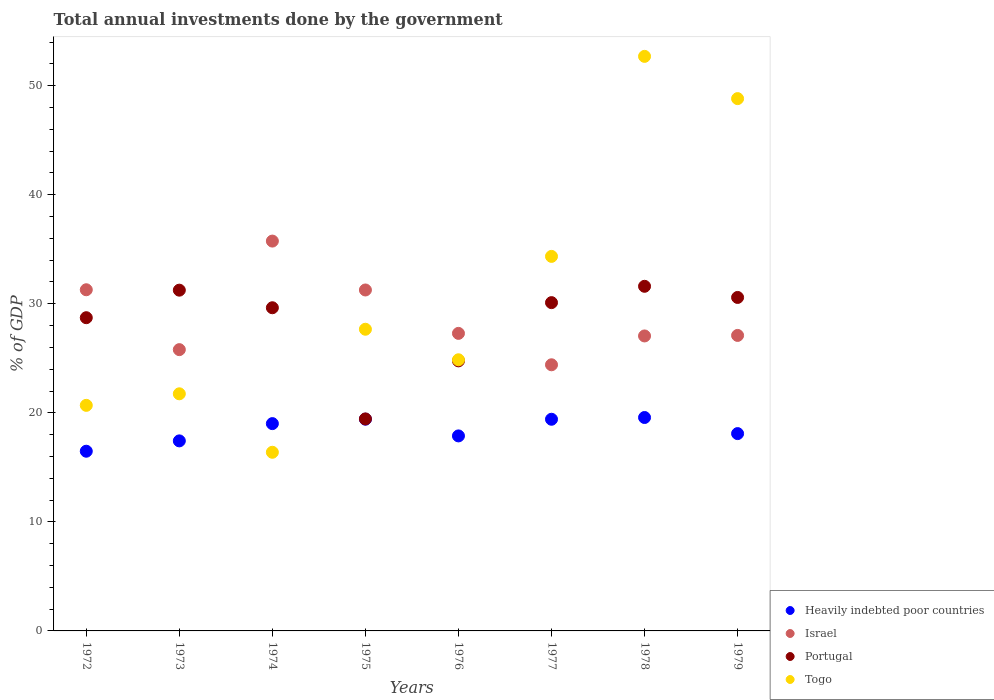Is the number of dotlines equal to the number of legend labels?
Your answer should be very brief. Yes. What is the total annual investments done by the government in Heavily indebted poor countries in 1972?
Your response must be concise. 16.48. Across all years, what is the maximum total annual investments done by the government in Togo?
Keep it short and to the point. 52.69. Across all years, what is the minimum total annual investments done by the government in Togo?
Give a very brief answer. 16.38. In which year was the total annual investments done by the government in Heavily indebted poor countries maximum?
Provide a succinct answer. 1978. In which year was the total annual investments done by the government in Togo minimum?
Provide a succinct answer. 1974. What is the total total annual investments done by the government in Israel in the graph?
Provide a short and direct response. 229.93. What is the difference between the total annual investments done by the government in Heavily indebted poor countries in 1972 and that in 1974?
Offer a very short reply. -2.53. What is the difference between the total annual investments done by the government in Heavily indebted poor countries in 1979 and the total annual investments done by the government in Israel in 1974?
Give a very brief answer. -17.65. What is the average total annual investments done by the government in Israel per year?
Offer a terse response. 28.74. In the year 1972, what is the difference between the total annual investments done by the government in Togo and total annual investments done by the government in Israel?
Make the answer very short. -10.6. What is the ratio of the total annual investments done by the government in Portugal in 1974 to that in 1977?
Make the answer very short. 0.98. Is the total annual investments done by the government in Israel in 1973 less than that in 1974?
Ensure brevity in your answer.  Yes. Is the difference between the total annual investments done by the government in Togo in 1973 and 1977 greater than the difference between the total annual investments done by the government in Israel in 1973 and 1977?
Provide a succinct answer. No. What is the difference between the highest and the second highest total annual investments done by the government in Portugal?
Provide a short and direct response. 0.35. What is the difference between the highest and the lowest total annual investments done by the government in Portugal?
Keep it short and to the point. 12.16. Is it the case that in every year, the sum of the total annual investments done by the government in Togo and total annual investments done by the government in Israel  is greater than the sum of total annual investments done by the government in Portugal and total annual investments done by the government in Heavily indebted poor countries?
Offer a terse response. No. Is the total annual investments done by the government in Portugal strictly greater than the total annual investments done by the government in Togo over the years?
Offer a terse response. No. How many dotlines are there?
Provide a succinct answer. 4. How many years are there in the graph?
Offer a very short reply. 8. Are the values on the major ticks of Y-axis written in scientific E-notation?
Keep it short and to the point. No. Does the graph contain grids?
Ensure brevity in your answer.  No. What is the title of the graph?
Offer a very short reply. Total annual investments done by the government. Does "Aruba" appear as one of the legend labels in the graph?
Your answer should be compact. No. What is the label or title of the X-axis?
Keep it short and to the point. Years. What is the label or title of the Y-axis?
Your response must be concise. % of GDP. What is the % of GDP in Heavily indebted poor countries in 1972?
Provide a succinct answer. 16.48. What is the % of GDP of Israel in 1972?
Provide a short and direct response. 31.29. What is the % of GDP of Portugal in 1972?
Your answer should be very brief. 28.72. What is the % of GDP in Togo in 1972?
Offer a very short reply. 20.69. What is the % of GDP in Heavily indebted poor countries in 1973?
Your answer should be compact. 17.43. What is the % of GDP in Israel in 1973?
Your answer should be very brief. 25.79. What is the % of GDP of Portugal in 1973?
Your response must be concise. 31.25. What is the % of GDP in Togo in 1973?
Provide a succinct answer. 21.74. What is the % of GDP in Heavily indebted poor countries in 1974?
Ensure brevity in your answer.  19.01. What is the % of GDP of Israel in 1974?
Your response must be concise. 35.75. What is the % of GDP in Portugal in 1974?
Give a very brief answer. 29.64. What is the % of GDP of Togo in 1974?
Your response must be concise. 16.38. What is the % of GDP in Heavily indebted poor countries in 1975?
Ensure brevity in your answer.  19.42. What is the % of GDP of Israel in 1975?
Give a very brief answer. 31.27. What is the % of GDP of Portugal in 1975?
Give a very brief answer. 19.44. What is the % of GDP in Togo in 1975?
Offer a very short reply. 27.66. What is the % of GDP of Heavily indebted poor countries in 1976?
Provide a succinct answer. 17.88. What is the % of GDP in Israel in 1976?
Provide a short and direct response. 27.29. What is the % of GDP in Portugal in 1976?
Give a very brief answer. 24.77. What is the % of GDP in Togo in 1976?
Provide a succinct answer. 24.86. What is the % of GDP of Heavily indebted poor countries in 1977?
Provide a short and direct response. 19.41. What is the % of GDP in Israel in 1977?
Offer a very short reply. 24.41. What is the % of GDP in Portugal in 1977?
Provide a succinct answer. 30.11. What is the % of GDP in Togo in 1977?
Your answer should be very brief. 34.35. What is the % of GDP in Heavily indebted poor countries in 1978?
Keep it short and to the point. 19.57. What is the % of GDP in Israel in 1978?
Provide a short and direct response. 27.05. What is the % of GDP in Portugal in 1978?
Keep it short and to the point. 31.6. What is the % of GDP in Togo in 1978?
Provide a succinct answer. 52.69. What is the % of GDP of Heavily indebted poor countries in 1979?
Provide a succinct answer. 18.09. What is the % of GDP of Israel in 1979?
Your answer should be compact. 27.1. What is the % of GDP in Portugal in 1979?
Give a very brief answer. 30.58. What is the % of GDP in Togo in 1979?
Keep it short and to the point. 48.81. Across all years, what is the maximum % of GDP in Heavily indebted poor countries?
Provide a short and direct response. 19.57. Across all years, what is the maximum % of GDP in Israel?
Keep it short and to the point. 35.75. Across all years, what is the maximum % of GDP of Portugal?
Offer a very short reply. 31.6. Across all years, what is the maximum % of GDP of Togo?
Ensure brevity in your answer.  52.69. Across all years, what is the minimum % of GDP of Heavily indebted poor countries?
Make the answer very short. 16.48. Across all years, what is the minimum % of GDP of Israel?
Offer a very short reply. 24.41. Across all years, what is the minimum % of GDP of Portugal?
Keep it short and to the point. 19.44. Across all years, what is the minimum % of GDP of Togo?
Offer a very short reply. 16.38. What is the total % of GDP of Heavily indebted poor countries in the graph?
Keep it short and to the point. 147.29. What is the total % of GDP of Israel in the graph?
Offer a terse response. 229.93. What is the total % of GDP in Portugal in the graph?
Keep it short and to the point. 226.1. What is the total % of GDP in Togo in the graph?
Your answer should be very brief. 247.19. What is the difference between the % of GDP in Heavily indebted poor countries in 1972 and that in 1973?
Your answer should be very brief. -0.95. What is the difference between the % of GDP in Israel in 1972 and that in 1973?
Offer a very short reply. 5.49. What is the difference between the % of GDP of Portugal in 1972 and that in 1973?
Give a very brief answer. -2.53. What is the difference between the % of GDP in Togo in 1972 and that in 1973?
Offer a terse response. -1.06. What is the difference between the % of GDP in Heavily indebted poor countries in 1972 and that in 1974?
Your answer should be compact. -2.53. What is the difference between the % of GDP in Israel in 1972 and that in 1974?
Your response must be concise. -4.46. What is the difference between the % of GDP in Portugal in 1972 and that in 1974?
Give a very brief answer. -0.91. What is the difference between the % of GDP in Togo in 1972 and that in 1974?
Provide a succinct answer. 4.3. What is the difference between the % of GDP of Heavily indebted poor countries in 1972 and that in 1975?
Your answer should be compact. -2.94. What is the difference between the % of GDP in Israel in 1972 and that in 1975?
Provide a short and direct response. 0.02. What is the difference between the % of GDP of Portugal in 1972 and that in 1975?
Provide a short and direct response. 9.28. What is the difference between the % of GDP in Togo in 1972 and that in 1975?
Offer a very short reply. -6.98. What is the difference between the % of GDP in Heavily indebted poor countries in 1972 and that in 1976?
Keep it short and to the point. -1.4. What is the difference between the % of GDP of Israel in 1972 and that in 1976?
Make the answer very short. 4. What is the difference between the % of GDP in Portugal in 1972 and that in 1976?
Offer a very short reply. 3.96. What is the difference between the % of GDP of Togo in 1972 and that in 1976?
Give a very brief answer. -4.18. What is the difference between the % of GDP of Heavily indebted poor countries in 1972 and that in 1977?
Make the answer very short. -2.93. What is the difference between the % of GDP in Israel in 1972 and that in 1977?
Your answer should be compact. 6.88. What is the difference between the % of GDP in Portugal in 1972 and that in 1977?
Your answer should be very brief. -1.38. What is the difference between the % of GDP of Togo in 1972 and that in 1977?
Provide a short and direct response. -13.66. What is the difference between the % of GDP in Heavily indebted poor countries in 1972 and that in 1978?
Make the answer very short. -3.09. What is the difference between the % of GDP of Israel in 1972 and that in 1978?
Offer a terse response. 4.24. What is the difference between the % of GDP in Portugal in 1972 and that in 1978?
Give a very brief answer. -2.88. What is the difference between the % of GDP of Togo in 1972 and that in 1978?
Your response must be concise. -32. What is the difference between the % of GDP of Heavily indebted poor countries in 1972 and that in 1979?
Give a very brief answer. -1.62. What is the difference between the % of GDP of Israel in 1972 and that in 1979?
Your answer should be compact. 4.19. What is the difference between the % of GDP of Portugal in 1972 and that in 1979?
Offer a very short reply. -1.86. What is the difference between the % of GDP of Togo in 1972 and that in 1979?
Provide a succinct answer. -28.13. What is the difference between the % of GDP of Heavily indebted poor countries in 1973 and that in 1974?
Offer a terse response. -1.58. What is the difference between the % of GDP of Israel in 1973 and that in 1974?
Provide a short and direct response. -9.95. What is the difference between the % of GDP of Portugal in 1973 and that in 1974?
Offer a terse response. 1.61. What is the difference between the % of GDP in Togo in 1973 and that in 1974?
Give a very brief answer. 5.36. What is the difference between the % of GDP in Heavily indebted poor countries in 1973 and that in 1975?
Offer a terse response. -1.99. What is the difference between the % of GDP of Israel in 1973 and that in 1975?
Your answer should be very brief. -5.47. What is the difference between the % of GDP in Portugal in 1973 and that in 1975?
Keep it short and to the point. 11.81. What is the difference between the % of GDP of Togo in 1973 and that in 1975?
Your response must be concise. -5.92. What is the difference between the % of GDP in Heavily indebted poor countries in 1973 and that in 1976?
Offer a very short reply. -0.46. What is the difference between the % of GDP in Israel in 1973 and that in 1976?
Your answer should be compact. -1.49. What is the difference between the % of GDP of Portugal in 1973 and that in 1976?
Provide a succinct answer. 6.48. What is the difference between the % of GDP of Togo in 1973 and that in 1976?
Offer a very short reply. -3.12. What is the difference between the % of GDP of Heavily indebted poor countries in 1973 and that in 1977?
Your answer should be very brief. -1.98. What is the difference between the % of GDP in Israel in 1973 and that in 1977?
Provide a short and direct response. 1.39. What is the difference between the % of GDP in Portugal in 1973 and that in 1977?
Offer a very short reply. 1.14. What is the difference between the % of GDP of Togo in 1973 and that in 1977?
Ensure brevity in your answer.  -12.6. What is the difference between the % of GDP of Heavily indebted poor countries in 1973 and that in 1978?
Make the answer very short. -2.14. What is the difference between the % of GDP in Israel in 1973 and that in 1978?
Your answer should be very brief. -1.26. What is the difference between the % of GDP in Portugal in 1973 and that in 1978?
Your answer should be very brief. -0.35. What is the difference between the % of GDP in Togo in 1973 and that in 1978?
Give a very brief answer. -30.94. What is the difference between the % of GDP of Heavily indebted poor countries in 1973 and that in 1979?
Keep it short and to the point. -0.67. What is the difference between the % of GDP in Israel in 1973 and that in 1979?
Your answer should be compact. -1.3. What is the difference between the % of GDP of Portugal in 1973 and that in 1979?
Your answer should be very brief. 0.67. What is the difference between the % of GDP in Togo in 1973 and that in 1979?
Ensure brevity in your answer.  -27.07. What is the difference between the % of GDP of Heavily indebted poor countries in 1974 and that in 1975?
Provide a short and direct response. -0.41. What is the difference between the % of GDP of Israel in 1974 and that in 1975?
Offer a very short reply. 4.48. What is the difference between the % of GDP in Portugal in 1974 and that in 1975?
Keep it short and to the point. 10.2. What is the difference between the % of GDP in Togo in 1974 and that in 1975?
Provide a short and direct response. -11.28. What is the difference between the % of GDP of Heavily indebted poor countries in 1974 and that in 1976?
Offer a very short reply. 1.13. What is the difference between the % of GDP of Israel in 1974 and that in 1976?
Your response must be concise. 8.46. What is the difference between the % of GDP of Portugal in 1974 and that in 1976?
Give a very brief answer. 4.87. What is the difference between the % of GDP of Togo in 1974 and that in 1976?
Provide a short and direct response. -8.48. What is the difference between the % of GDP in Heavily indebted poor countries in 1974 and that in 1977?
Ensure brevity in your answer.  -0.4. What is the difference between the % of GDP of Israel in 1974 and that in 1977?
Your answer should be compact. 11.34. What is the difference between the % of GDP in Portugal in 1974 and that in 1977?
Provide a short and direct response. -0.47. What is the difference between the % of GDP of Togo in 1974 and that in 1977?
Make the answer very short. -17.96. What is the difference between the % of GDP of Heavily indebted poor countries in 1974 and that in 1978?
Give a very brief answer. -0.56. What is the difference between the % of GDP in Israel in 1974 and that in 1978?
Your answer should be compact. 8.7. What is the difference between the % of GDP in Portugal in 1974 and that in 1978?
Make the answer very short. -1.97. What is the difference between the % of GDP in Togo in 1974 and that in 1978?
Provide a succinct answer. -36.31. What is the difference between the % of GDP in Heavily indebted poor countries in 1974 and that in 1979?
Offer a terse response. 0.92. What is the difference between the % of GDP of Israel in 1974 and that in 1979?
Keep it short and to the point. 8.65. What is the difference between the % of GDP of Portugal in 1974 and that in 1979?
Offer a terse response. -0.94. What is the difference between the % of GDP in Togo in 1974 and that in 1979?
Your response must be concise. -32.43. What is the difference between the % of GDP of Heavily indebted poor countries in 1975 and that in 1976?
Give a very brief answer. 1.53. What is the difference between the % of GDP in Israel in 1975 and that in 1976?
Give a very brief answer. 3.98. What is the difference between the % of GDP in Portugal in 1975 and that in 1976?
Ensure brevity in your answer.  -5.32. What is the difference between the % of GDP in Togo in 1975 and that in 1976?
Make the answer very short. 2.8. What is the difference between the % of GDP of Heavily indebted poor countries in 1975 and that in 1977?
Provide a succinct answer. 0.01. What is the difference between the % of GDP in Israel in 1975 and that in 1977?
Offer a terse response. 6.86. What is the difference between the % of GDP in Portugal in 1975 and that in 1977?
Keep it short and to the point. -10.66. What is the difference between the % of GDP of Togo in 1975 and that in 1977?
Your answer should be compact. -6.68. What is the difference between the % of GDP in Heavily indebted poor countries in 1975 and that in 1978?
Offer a very short reply. -0.15. What is the difference between the % of GDP in Israel in 1975 and that in 1978?
Give a very brief answer. 4.22. What is the difference between the % of GDP in Portugal in 1975 and that in 1978?
Keep it short and to the point. -12.16. What is the difference between the % of GDP of Togo in 1975 and that in 1978?
Provide a succinct answer. -25.02. What is the difference between the % of GDP in Heavily indebted poor countries in 1975 and that in 1979?
Provide a succinct answer. 1.32. What is the difference between the % of GDP in Israel in 1975 and that in 1979?
Give a very brief answer. 4.17. What is the difference between the % of GDP in Portugal in 1975 and that in 1979?
Your answer should be very brief. -11.14. What is the difference between the % of GDP in Togo in 1975 and that in 1979?
Offer a terse response. -21.15. What is the difference between the % of GDP of Heavily indebted poor countries in 1976 and that in 1977?
Make the answer very short. -1.53. What is the difference between the % of GDP in Israel in 1976 and that in 1977?
Give a very brief answer. 2.88. What is the difference between the % of GDP in Portugal in 1976 and that in 1977?
Provide a succinct answer. -5.34. What is the difference between the % of GDP in Togo in 1976 and that in 1977?
Provide a succinct answer. -9.48. What is the difference between the % of GDP in Heavily indebted poor countries in 1976 and that in 1978?
Offer a terse response. -1.69. What is the difference between the % of GDP of Israel in 1976 and that in 1978?
Provide a short and direct response. 0.24. What is the difference between the % of GDP of Portugal in 1976 and that in 1978?
Give a very brief answer. -6.84. What is the difference between the % of GDP in Togo in 1976 and that in 1978?
Your response must be concise. -27.82. What is the difference between the % of GDP in Heavily indebted poor countries in 1976 and that in 1979?
Ensure brevity in your answer.  -0.21. What is the difference between the % of GDP in Israel in 1976 and that in 1979?
Keep it short and to the point. 0.19. What is the difference between the % of GDP in Portugal in 1976 and that in 1979?
Give a very brief answer. -5.82. What is the difference between the % of GDP in Togo in 1976 and that in 1979?
Your answer should be very brief. -23.95. What is the difference between the % of GDP of Heavily indebted poor countries in 1977 and that in 1978?
Offer a terse response. -0.16. What is the difference between the % of GDP of Israel in 1977 and that in 1978?
Your response must be concise. -2.64. What is the difference between the % of GDP of Portugal in 1977 and that in 1978?
Give a very brief answer. -1.5. What is the difference between the % of GDP in Togo in 1977 and that in 1978?
Provide a succinct answer. -18.34. What is the difference between the % of GDP in Heavily indebted poor countries in 1977 and that in 1979?
Offer a terse response. 1.32. What is the difference between the % of GDP in Israel in 1977 and that in 1979?
Offer a very short reply. -2.69. What is the difference between the % of GDP in Portugal in 1977 and that in 1979?
Your response must be concise. -0.48. What is the difference between the % of GDP of Togo in 1977 and that in 1979?
Give a very brief answer. -14.47. What is the difference between the % of GDP in Heavily indebted poor countries in 1978 and that in 1979?
Offer a very short reply. 1.48. What is the difference between the % of GDP of Israel in 1978 and that in 1979?
Your answer should be very brief. -0.05. What is the difference between the % of GDP of Portugal in 1978 and that in 1979?
Give a very brief answer. 1.02. What is the difference between the % of GDP of Togo in 1978 and that in 1979?
Your answer should be very brief. 3.87. What is the difference between the % of GDP in Heavily indebted poor countries in 1972 and the % of GDP in Israel in 1973?
Offer a very short reply. -9.32. What is the difference between the % of GDP in Heavily indebted poor countries in 1972 and the % of GDP in Portugal in 1973?
Make the answer very short. -14.77. What is the difference between the % of GDP in Heavily indebted poor countries in 1972 and the % of GDP in Togo in 1973?
Offer a terse response. -5.26. What is the difference between the % of GDP of Israel in 1972 and the % of GDP of Portugal in 1973?
Make the answer very short. 0.04. What is the difference between the % of GDP in Israel in 1972 and the % of GDP in Togo in 1973?
Give a very brief answer. 9.54. What is the difference between the % of GDP of Portugal in 1972 and the % of GDP of Togo in 1973?
Provide a succinct answer. 6.98. What is the difference between the % of GDP of Heavily indebted poor countries in 1972 and the % of GDP of Israel in 1974?
Your answer should be compact. -19.27. What is the difference between the % of GDP in Heavily indebted poor countries in 1972 and the % of GDP in Portugal in 1974?
Provide a succinct answer. -13.16. What is the difference between the % of GDP in Heavily indebted poor countries in 1972 and the % of GDP in Togo in 1974?
Give a very brief answer. 0.1. What is the difference between the % of GDP of Israel in 1972 and the % of GDP of Portugal in 1974?
Keep it short and to the point. 1.65. What is the difference between the % of GDP in Israel in 1972 and the % of GDP in Togo in 1974?
Your answer should be very brief. 14.9. What is the difference between the % of GDP in Portugal in 1972 and the % of GDP in Togo in 1974?
Give a very brief answer. 12.34. What is the difference between the % of GDP of Heavily indebted poor countries in 1972 and the % of GDP of Israel in 1975?
Ensure brevity in your answer.  -14.79. What is the difference between the % of GDP in Heavily indebted poor countries in 1972 and the % of GDP in Portugal in 1975?
Provide a short and direct response. -2.96. What is the difference between the % of GDP in Heavily indebted poor countries in 1972 and the % of GDP in Togo in 1975?
Give a very brief answer. -11.19. What is the difference between the % of GDP in Israel in 1972 and the % of GDP in Portugal in 1975?
Provide a succinct answer. 11.84. What is the difference between the % of GDP of Israel in 1972 and the % of GDP of Togo in 1975?
Offer a very short reply. 3.62. What is the difference between the % of GDP in Portugal in 1972 and the % of GDP in Togo in 1975?
Keep it short and to the point. 1.06. What is the difference between the % of GDP of Heavily indebted poor countries in 1972 and the % of GDP of Israel in 1976?
Provide a succinct answer. -10.81. What is the difference between the % of GDP of Heavily indebted poor countries in 1972 and the % of GDP of Portugal in 1976?
Provide a succinct answer. -8.29. What is the difference between the % of GDP in Heavily indebted poor countries in 1972 and the % of GDP in Togo in 1976?
Your answer should be compact. -8.39. What is the difference between the % of GDP of Israel in 1972 and the % of GDP of Portugal in 1976?
Your response must be concise. 6.52. What is the difference between the % of GDP of Israel in 1972 and the % of GDP of Togo in 1976?
Give a very brief answer. 6.42. What is the difference between the % of GDP of Portugal in 1972 and the % of GDP of Togo in 1976?
Offer a very short reply. 3.86. What is the difference between the % of GDP of Heavily indebted poor countries in 1972 and the % of GDP of Israel in 1977?
Make the answer very short. -7.93. What is the difference between the % of GDP of Heavily indebted poor countries in 1972 and the % of GDP of Portugal in 1977?
Give a very brief answer. -13.63. What is the difference between the % of GDP of Heavily indebted poor countries in 1972 and the % of GDP of Togo in 1977?
Offer a very short reply. -17.87. What is the difference between the % of GDP of Israel in 1972 and the % of GDP of Portugal in 1977?
Offer a very short reply. 1.18. What is the difference between the % of GDP in Israel in 1972 and the % of GDP in Togo in 1977?
Your answer should be very brief. -3.06. What is the difference between the % of GDP in Portugal in 1972 and the % of GDP in Togo in 1977?
Ensure brevity in your answer.  -5.62. What is the difference between the % of GDP in Heavily indebted poor countries in 1972 and the % of GDP in Israel in 1978?
Offer a terse response. -10.57. What is the difference between the % of GDP of Heavily indebted poor countries in 1972 and the % of GDP of Portugal in 1978?
Your answer should be very brief. -15.12. What is the difference between the % of GDP of Heavily indebted poor countries in 1972 and the % of GDP of Togo in 1978?
Provide a succinct answer. -36.21. What is the difference between the % of GDP of Israel in 1972 and the % of GDP of Portugal in 1978?
Your answer should be compact. -0.32. What is the difference between the % of GDP in Israel in 1972 and the % of GDP in Togo in 1978?
Make the answer very short. -21.4. What is the difference between the % of GDP in Portugal in 1972 and the % of GDP in Togo in 1978?
Offer a terse response. -23.96. What is the difference between the % of GDP in Heavily indebted poor countries in 1972 and the % of GDP in Israel in 1979?
Ensure brevity in your answer.  -10.62. What is the difference between the % of GDP of Heavily indebted poor countries in 1972 and the % of GDP of Portugal in 1979?
Your answer should be very brief. -14.1. What is the difference between the % of GDP of Heavily indebted poor countries in 1972 and the % of GDP of Togo in 1979?
Your response must be concise. -32.33. What is the difference between the % of GDP of Israel in 1972 and the % of GDP of Portugal in 1979?
Provide a succinct answer. 0.7. What is the difference between the % of GDP in Israel in 1972 and the % of GDP in Togo in 1979?
Offer a very short reply. -17.53. What is the difference between the % of GDP of Portugal in 1972 and the % of GDP of Togo in 1979?
Provide a succinct answer. -20.09. What is the difference between the % of GDP of Heavily indebted poor countries in 1973 and the % of GDP of Israel in 1974?
Give a very brief answer. -18.32. What is the difference between the % of GDP in Heavily indebted poor countries in 1973 and the % of GDP in Portugal in 1974?
Provide a short and direct response. -12.21. What is the difference between the % of GDP of Heavily indebted poor countries in 1973 and the % of GDP of Togo in 1974?
Your answer should be compact. 1.04. What is the difference between the % of GDP in Israel in 1973 and the % of GDP in Portugal in 1974?
Ensure brevity in your answer.  -3.84. What is the difference between the % of GDP of Israel in 1973 and the % of GDP of Togo in 1974?
Your answer should be very brief. 9.41. What is the difference between the % of GDP of Portugal in 1973 and the % of GDP of Togo in 1974?
Keep it short and to the point. 14.87. What is the difference between the % of GDP in Heavily indebted poor countries in 1973 and the % of GDP in Israel in 1975?
Your answer should be very brief. -13.84. What is the difference between the % of GDP of Heavily indebted poor countries in 1973 and the % of GDP of Portugal in 1975?
Offer a very short reply. -2.01. What is the difference between the % of GDP in Heavily indebted poor countries in 1973 and the % of GDP in Togo in 1975?
Provide a short and direct response. -10.24. What is the difference between the % of GDP of Israel in 1973 and the % of GDP of Portugal in 1975?
Give a very brief answer. 6.35. What is the difference between the % of GDP of Israel in 1973 and the % of GDP of Togo in 1975?
Make the answer very short. -1.87. What is the difference between the % of GDP in Portugal in 1973 and the % of GDP in Togo in 1975?
Offer a very short reply. 3.58. What is the difference between the % of GDP of Heavily indebted poor countries in 1973 and the % of GDP of Israel in 1976?
Your answer should be very brief. -9.86. What is the difference between the % of GDP of Heavily indebted poor countries in 1973 and the % of GDP of Portugal in 1976?
Make the answer very short. -7.34. What is the difference between the % of GDP in Heavily indebted poor countries in 1973 and the % of GDP in Togo in 1976?
Your answer should be very brief. -7.44. What is the difference between the % of GDP of Israel in 1973 and the % of GDP of Portugal in 1976?
Offer a terse response. 1.03. What is the difference between the % of GDP in Israel in 1973 and the % of GDP in Togo in 1976?
Make the answer very short. 0.93. What is the difference between the % of GDP of Portugal in 1973 and the % of GDP of Togo in 1976?
Your answer should be very brief. 6.38. What is the difference between the % of GDP of Heavily indebted poor countries in 1973 and the % of GDP of Israel in 1977?
Your answer should be compact. -6.98. What is the difference between the % of GDP of Heavily indebted poor countries in 1973 and the % of GDP of Portugal in 1977?
Your answer should be very brief. -12.68. What is the difference between the % of GDP in Heavily indebted poor countries in 1973 and the % of GDP in Togo in 1977?
Keep it short and to the point. -16.92. What is the difference between the % of GDP in Israel in 1973 and the % of GDP in Portugal in 1977?
Provide a short and direct response. -4.31. What is the difference between the % of GDP in Israel in 1973 and the % of GDP in Togo in 1977?
Your answer should be very brief. -8.55. What is the difference between the % of GDP of Portugal in 1973 and the % of GDP of Togo in 1977?
Provide a short and direct response. -3.1. What is the difference between the % of GDP in Heavily indebted poor countries in 1973 and the % of GDP in Israel in 1978?
Your answer should be very brief. -9.62. What is the difference between the % of GDP in Heavily indebted poor countries in 1973 and the % of GDP in Portugal in 1978?
Make the answer very short. -14.18. What is the difference between the % of GDP in Heavily indebted poor countries in 1973 and the % of GDP in Togo in 1978?
Your answer should be very brief. -35.26. What is the difference between the % of GDP in Israel in 1973 and the % of GDP in Portugal in 1978?
Keep it short and to the point. -5.81. What is the difference between the % of GDP in Israel in 1973 and the % of GDP in Togo in 1978?
Provide a succinct answer. -26.89. What is the difference between the % of GDP in Portugal in 1973 and the % of GDP in Togo in 1978?
Your answer should be compact. -21.44. What is the difference between the % of GDP in Heavily indebted poor countries in 1973 and the % of GDP in Israel in 1979?
Keep it short and to the point. -9.67. What is the difference between the % of GDP of Heavily indebted poor countries in 1973 and the % of GDP of Portugal in 1979?
Provide a succinct answer. -13.15. What is the difference between the % of GDP in Heavily indebted poor countries in 1973 and the % of GDP in Togo in 1979?
Provide a short and direct response. -31.39. What is the difference between the % of GDP of Israel in 1973 and the % of GDP of Portugal in 1979?
Keep it short and to the point. -4.79. What is the difference between the % of GDP in Israel in 1973 and the % of GDP in Togo in 1979?
Make the answer very short. -23.02. What is the difference between the % of GDP in Portugal in 1973 and the % of GDP in Togo in 1979?
Offer a terse response. -17.57. What is the difference between the % of GDP of Heavily indebted poor countries in 1974 and the % of GDP of Israel in 1975?
Your response must be concise. -12.26. What is the difference between the % of GDP in Heavily indebted poor countries in 1974 and the % of GDP in Portugal in 1975?
Provide a short and direct response. -0.43. What is the difference between the % of GDP in Heavily indebted poor countries in 1974 and the % of GDP in Togo in 1975?
Your answer should be compact. -8.65. What is the difference between the % of GDP in Israel in 1974 and the % of GDP in Portugal in 1975?
Offer a terse response. 16.31. What is the difference between the % of GDP of Israel in 1974 and the % of GDP of Togo in 1975?
Offer a terse response. 8.09. What is the difference between the % of GDP in Portugal in 1974 and the % of GDP in Togo in 1975?
Offer a terse response. 1.97. What is the difference between the % of GDP of Heavily indebted poor countries in 1974 and the % of GDP of Israel in 1976?
Keep it short and to the point. -8.28. What is the difference between the % of GDP in Heavily indebted poor countries in 1974 and the % of GDP in Portugal in 1976?
Your response must be concise. -5.76. What is the difference between the % of GDP in Heavily indebted poor countries in 1974 and the % of GDP in Togo in 1976?
Offer a terse response. -5.85. What is the difference between the % of GDP in Israel in 1974 and the % of GDP in Portugal in 1976?
Your response must be concise. 10.98. What is the difference between the % of GDP in Israel in 1974 and the % of GDP in Togo in 1976?
Give a very brief answer. 10.88. What is the difference between the % of GDP in Portugal in 1974 and the % of GDP in Togo in 1976?
Your response must be concise. 4.77. What is the difference between the % of GDP of Heavily indebted poor countries in 1974 and the % of GDP of Israel in 1977?
Give a very brief answer. -5.4. What is the difference between the % of GDP in Heavily indebted poor countries in 1974 and the % of GDP in Portugal in 1977?
Keep it short and to the point. -11.1. What is the difference between the % of GDP in Heavily indebted poor countries in 1974 and the % of GDP in Togo in 1977?
Provide a succinct answer. -15.34. What is the difference between the % of GDP of Israel in 1974 and the % of GDP of Portugal in 1977?
Give a very brief answer. 5.64. What is the difference between the % of GDP of Israel in 1974 and the % of GDP of Togo in 1977?
Make the answer very short. 1.4. What is the difference between the % of GDP in Portugal in 1974 and the % of GDP in Togo in 1977?
Your response must be concise. -4.71. What is the difference between the % of GDP of Heavily indebted poor countries in 1974 and the % of GDP of Israel in 1978?
Keep it short and to the point. -8.04. What is the difference between the % of GDP in Heavily indebted poor countries in 1974 and the % of GDP in Portugal in 1978?
Provide a short and direct response. -12.59. What is the difference between the % of GDP of Heavily indebted poor countries in 1974 and the % of GDP of Togo in 1978?
Make the answer very short. -33.68. What is the difference between the % of GDP in Israel in 1974 and the % of GDP in Portugal in 1978?
Keep it short and to the point. 4.15. What is the difference between the % of GDP in Israel in 1974 and the % of GDP in Togo in 1978?
Offer a terse response. -16.94. What is the difference between the % of GDP of Portugal in 1974 and the % of GDP of Togo in 1978?
Provide a short and direct response. -23.05. What is the difference between the % of GDP in Heavily indebted poor countries in 1974 and the % of GDP in Israel in 1979?
Your answer should be very brief. -8.09. What is the difference between the % of GDP in Heavily indebted poor countries in 1974 and the % of GDP in Portugal in 1979?
Your answer should be very brief. -11.57. What is the difference between the % of GDP of Heavily indebted poor countries in 1974 and the % of GDP of Togo in 1979?
Your response must be concise. -29.8. What is the difference between the % of GDP in Israel in 1974 and the % of GDP in Portugal in 1979?
Offer a terse response. 5.17. What is the difference between the % of GDP of Israel in 1974 and the % of GDP of Togo in 1979?
Ensure brevity in your answer.  -13.06. What is the difference between the % of GDP in Portugal in 1974 and the % of GDP in Togo in 1979?
Give a very brief answer. -19.18. What is the difference between the % of GDP of Heavily indebted poor countries in 1975 and the % of GDP of Israel in 1976?
Keep it short and to the point. -7.87. What is the difference between the % of GDP in Heavily indebted poor countries in 1975 and the % of GDP in Portugal in 1976?
Offer a very short reply. -5.35. What is the difference between the % of GDP of Heavily indebted poor countries in 1975 and the % of GDP of Togo in 1976?
Offer a terse response. -5.45. What is the difference between the % of GDP of Israel in 1975 and the % of GDP of Portugal in 1976?
Make the answer very short. 6.5. What is the difference between the % of GDP of Israel in 1975 and the % of GDP of Togo in 1976?
Offer a very short reply. 6.4. What is the difference between the % of GDP of Portugal in 1975 and the % of GDP of Togo in 1976?
Keep it short and to the point. -5.42. What is the difference between the % of GDP in Heavily indebted poor countries in 1975 and the % of GDP in Israel in 1977?
Give a very brief answer. -4.99. What is the difference between the % of GDP of Heavily indebted poor countries in 1975 and the % of GDP of Portugal in 1977?
Your answer should be compact. -10.69. What is the difference between the % of GDP in Heavily indebted poor countries in 1975 and the % of GDP in Togo in 1977?
Your answer should be very brief. -14.93. What is the difference between the % of GDP of Israel in 1975 and the % of GDP of Portugal in 1977?
Offer a very short reply. 1.16. What is the difference between the % of GDP of Israel in 1975 and the % of GDP of Togo in 1977?
Offer a very short reply. -3.08. What is the difference between the % of GDP of Portugal in 1975 and the % of GDP of Togo in 1977?
Provide a short and direct response. -14.9. What is the difference between the % of GDP of Heavily indebted poor countries in 1975 and the % of GDP of Israel in 1978?
Give a very brief answer. -7.63. What is the difference between the % of GDP in Heavily indebted poor countries in 1975 and the % of GDP in Portugal in 1978?
Your response must be concise. -12.19. What is the difference between the % of GDP in Heavily indebted poor countries in 1975 and the % of GDP in Togo in 1978?
Offer a terse response. -33.27. What is the difference between the % of GDP of Israel in 1975 and the % of GDP of Portugal in 1978?
Give a very brief answer. -0.34. What is the difference between the % of GDP in Israel in 1975 and the % of GDP in Togo in 1978?
Give a very brief answer. -21.42. What is the difference between the % of GDP of Portugal in 1975 and the % of GDP of Togo in 1978?
Offer a very short reply. -33.25. What is the difference between the % of GDP of Heavily indebted poor countries in 1975 and the % of GDP of Israel in 1979?
Ensure brevity in your answer.  -7.68. What is the difference between the % of GDP in Heavily indebted poor countries in 1975 and the % of GDP in Portugal in 1979?
Your answer should be compact. -11.16. What is the difference between the % of GDP of Heavily indebted poor countries in 1975 and the % of GDP of Togo in 1979?
Provide a succinct answer. -29.4. What is the difference between the % of GDP in Israel in 1975 and the % of GDP in Portugal in 1979?
Your answer should be very brief. 0.68. What is the difference between the % of GDP in Israel in 1975 and the % of GDP in Togo in 1979?
Provide a short and direct response. -17.55. What is the difference between the % of GDP in Portugal in 1975 and the % of GDP in Togo in 1979?
Provide a short and direct response. -29.37. What is the difference between the % of GDP of Heavily indebted poor countries in 1976 and the % of GDP of Israel in 1977?
Your response must be concise. -6.52. What is the difference between the % of GDP in Heavily indebted poor countries in 1976 and the % of GDP in Portugal in 1977?
Ensure brevity in your answer.  -12.22. What is the difference between the % of GDP in Heavily indebted poor countries in 1976 and the % of GDP in Togo in 1977?
Offer a terse response. -16.46. What is the difference between the % of GDP in Israel in 1976 and the % of GDP in Portugal in 1977?
Ensure brevity in your answer.  -2.82. What is the difference between the % of GDP in Israel in 1976 and the % of GDP in Togo in 1977?
Provide a short and direct response. -7.06. What is the difference between the % of GDP in Portugal in 1976 and the % of GDP in Togo in 1977?
Keep it short and to the point. -9.58. What is the difference between the % of GDP of Heavily indebted poor countries in 1976 and the % of GDP of Israel in 1978?
Offer a very short reply. -9.17. What is the difference between the % of GDP in Heavily indebted poor countries in 1976 and the % of GDP in Portugal in 1978?
Your response must be concise. -13.72. What is the difference between the % of GDP in Heavily indebted poor countries in 1976 and the % of GDP in Togo in 1978?
Ensure brevity in your answer.  -34.8. What is the difference between the % of GDP in Israel in 1976 and the % of GDP in Portugal in 1978?
Your answer should be very brief. -4.32. What is the difference between the % of GDP of Israel in 1976 and the % of GDP of Togo in 1978?
Provide a short and direct response. -25.4. What is the difference between the % of GDP of Portugal in 1976 and the % of GDP of Togo in 1978?
Keep it short and to the point. -27.92. What is the difference between the % of GDP in Heavily indebted poor countries in 1976 and the % of GDP in Israel in 1979?
Give a very brief answer. -9.21. What is the difference between the % of GDP in Heavily indebted poor countries in 1976 and the % of GDP in Portugal in 1979?
Ensure brevity in your answer.  -12.7. What is the difference between the % of GDP of Heavily indebted poor countries in 1976 and the % of GDP of Togo in 1979?
Keep it short and to the point. -30.93. What is the difference between the % of GDP of Israel in 1976 and the % of GDP of Portugal in 1979?
Make the answer very short. -3.29. What is the difference between the % of GDP in Israel in 1976 and the % of GDP in Togo in 1979?
Offer a very short reply. -21.53. What is the difference between the % of GDP in Portugal in 1976 and the % of GDP in Togo in 1979?
Your response must be concise. -24.05. What is the difference between the % of GDP in Heavily indebted poor countries in 1977 and the % of GDP in Israel in 1978?
Your response must be concise. -7.64. What is the difference between the % of GDP of Heavily indebted poor countries in 1977 and the % of GDP of Portugal in 1978?
Offer a very short reply. -12.19. What is the difference between the % of GDP of Heavily indebted poor countries in 1977 and the % of GDP of Togo in 1978?
Your answer should be very brief. -33.28. What is the difference between the % of GDP in Israel in 1977 and the % of GDP in Portugal in 1978?
Provide a succinct answer. -7.2. What is the difference between the % of GDP of Israel in 1977 and the % of GDP of Togo in 1978?
Your answer should be compact. -28.28. What is the difference between the % of GDP of Portugal in 1977 and the % of GDP of Togo in 1978?
Make the answer very short. -22.58. What is the difference between the % of GDP in Heavily indebted poor countries in 1977 and the % of GDP in Israel in 1979?
Keep it short and to the point. -7.69. What is the difference between the % of GDP in Heavily indebted poor countries in 1977 and the % of GDP in Portugal in 1979?
Provide a short and direct response. -11.17. What is the difference between the % of GDP in Heavily indebted poor countries in 1977 and the % of GDP in Togo in 1979?
Your answer should be compact. -29.4. What is the difference between the % of GDP in Israel in 1977 and the % of GDP in Portugal in 1979?
Offer a terse response. -6.17. What is the difference between the % of GDP of Israel in 1977 and the % of GDP of Togo in 1979?
Your answer should be compact. -24.41. What is the difference between the % of GDP of Portugal in 1977 and the % of GDP of Togo in 1979?
Ensure brevity in your answer.  -18.71. What is the difference between the % of GDP in Heavily indebted poor countries in 1978 and the % of GDP in Israel in 1979?
Keep it short and to the point. -7.53. What is the difference between the % of GDP of Heavily indebted poor countries in 1978 and the % of GDP of Portugal in 1979?
Offer a terse response. -11.01. What is the difference between the % of GDP in Heavily indebted poor countries in 1978 and the % of GDP in Togo in 1979?
Provide a short and direct response. -29.24. What is the difference between the % of GDP of Israel in 1978 and the % of GDP of Portugal in 1979?
Provide a succinct answer. -3.53. What is the difference between the % of GDP of Israel in 1978 and the % of GDP of Togo in 1979?
Provide a succinct answer. -21.76. What is the difference between the % of GDP in Portugal in 1978 and the % of GDP in Togo in 1979?
Your response must be concise. -17.21. What is the average % of GDP in Heavily indebted poor countries per year?
Your answer should be very brief. 18.41. What is the average % of GDP of Israel per year?
Give a very brief answer. 28.74. What is the average % of GDP in Portugal per year?
Give a very brief answer. 28.26. What is the average % of GDP of Togo per year?
Your answer should be very brief. 30.9. In the year 1972, what is the difference between the % of GDP in Heavily indebted poor countries and % of GDP in Israel?
Offer a terse response. -14.81. In the year 1972, what is the difference between the % of GDP of Heavily indebted poor countries and % of GDP of Portugal?
Your response must be concise. -12.24. In the year 1972, what is the difference between the % of GDP of Heavily indebted poor countries and % of GDP of Togo?
Keep it short and to the point. -4.21. In the year 1972, what is the difference between the % of GDP of Israel and % of GDP of Portugal?
Ensure brevity in your answer.  2.56. In the year 1972, what is the difference between the % of GDP in Israel and % of GDP in Togo?
Offer a very short reply. 10.6. In the year 1972, what is the difference between the % of GDP in Portugal and % of GDP in Togo?
Your answer should be very brief. 8.04. In the year 1973, what is the difference between the % of GDP of Heavily indebted poor countries and % of GDP of Israel?
Provide a short and direct response. -8.37. In the year 1973, what is the difference between the % of GDP in Heavily indebted poor countries and % of GDP in Portugal?
Keep it short and to the point. -13.82. In the year 1973, what is the difference between the % of GDP of Heavily indebted poor countries and % of GDP of Togo?
Make the answer very short. -4.32. In the year 1973, what is the difference between the % of GDP in Israel and % of GDP in Portugal?
Keep it short and to the point. -5.45. In the year 1973, what is the difference between the % of GDP of Israel and % of GDP of Togo?
Provide a succinct answer. 4.05. In the year 1973, what is the difference between the % of GDP of Portugal and % of GDP of Togo?
Your answer should be very brief. 9.5. In the year 1974, what is the difference between the % of GDP of Heavily indebted poor countries and % of GDP of Israel?
Your response must be concise. -16.74. In the year 1974, what is the difference between the % of GDP of Heavily indebted poor countries and % of GDP of Portugal?
Keep it short and to the point. -10.63. In the year 1974, what is the difference between the % of GDP of Heavily indebted poor countries and % of GDP of Togo?
Keep it short and to the point. 2.63. In the year 1974, what is the difference between the % of GDP in Israel and % of GDP in Portugal?
Keep it short and to the point. 6.11. In the year 1974, what is the difference between the % of GDP of Israel and % of GDP of Togo?
Ensure brevity in your answer.  19.37. In the year 1974, what is the difference between the % of GDP in Portugal and % of GDP in Togo?
Make the answer very short. 13.25. In the year 1975, what is the difference between the % of GDP of Heavily indebted poor countries and % of GDP of Israel?
Your answer should be compact. -11.85. In the year 1975, what is the difference between the % of GDP of Heavily indebted poor countries and % of GDP of Portugal?
Keep it short and to the point. -0.02. In the year 1975, what is the difference between the % of GDP in Heavily indebted poor countries and % of GDP in Togo?
Give a very brief answer. -8.25. In the year 1975, what is the difference between the % of GDP of Israel and % of GDP of Portugal?
Provide a short and direct response. 11.82. In the year 1975, what is the difference between the % of GDP of Israel and % of GDP of Togo?
Provide a short and direct response. 3.6. In the year 1975, what is the difference between the % of GDP in Portugal and % of GDP in Togo?
Give a very brief answer. -8.22. In the year 1976, what is the difference between the % of GDP in Heavily indebted poor countries and % of GDP in Israel?
Your answer should be compact. -9.4. In the year 1976, what is the difference between the % of GDP of Heavily indebted poor countries and % of GDP of Portugal?
Provide a short and direct response. -6.88. In the year 1976, what is the difference between the % of GDP in Heavily indebted poor countries and % of GDP in Togo?
Provide a succinct answer. -6.98. In the year 1976, what is the difference between the % of GDP in Israel and % of GDP in Portugal?
Give a very brief answer. 2.52. In the year 1976, what is the difference between the % of GDP of Israel and % of GDP of Togo?
Provide a short and direct response. 2.42. In the year 1976, what is the difference between the % of GDP in Portugal and % of GDP in Togo?
Your response must be concise. -0.1. In the year 1977, what is the difference between the % of GDP in Heavily indebted poor countries and % of GDP in Israel?
Keep it short and to the point. -5. In the year 1977, what is the difference between the % of GDP in Heavily indebted poor countries and % of GDP in Portugal?
Your answer should be compact. -10.69. In the year 1977, what is the difference between the % of GDP in Heavily indebted poor countries and % of GDP in Togo?
Provide a succinct answer. -14.94. In the year 1977, what is the difference between the % of GDP of Israel and % of GDP of Portugal?
Give a very brief answer. -5.7. In the year 1977, what is the difference between the % of GDP in Israel and % of GDP in Togo?
Keep it short and to the point. -9.94. In the year 1977, what is the difference between the % of GDP of Portugal and % of GDP of Togo?
Offer a very short reply. -4.24. In the year 1978, what is the difference between the % of GDP in Heavily indebted poor countries and % of GDP in Israel?
Your response must be concise. -7.48. In the year 1978, what is the difference between the % of GDP of Heavily indebted poor countries and % of GDP of Portugal?
Make the answer very short. -12.03. In the year 1978, what is the difference between the % of GDP in Heavily indebted poor countries and % of GDP in Togo?
Provide a short and direct response. -33.12. In the year 1978, what is the difference between the % of GDP of Israel and % of GDP of Portugal?
Keep it short and to the point. -4.55. In the year 1978, what is the difference between the % of GDP in Israel and % of GDP in Togo?
Ensure brevity in your answer.  -25.64. In the year 1978, what is the difference between the % of GDP of Portugal and % of GDP of Togo?
Provide a short and direct response. -21.09. In the year 1979, what is the difference between the % of GDP in Heavily indebted poor countries and % of GDP in Israel?
Offer a very short reply. -9. In the year 1979, what is the difference between the % of GDP in Heavily indebted poor countries and % of GDP in Portugal?
Give a very brief answer. -12.49. In the year 1979, what is the difference between the % of GDP in Heavily indebted poor countries and % of GDP in Togo?
Offer a very short reply. -30.72. In the year 1979, what is the difference between the % of GDP in Israel and % of GDP in Portugal?
Offer a very short reply. -3.48. In the year 1979, what is the difference between the % of GDP in Israel and % of GDP in Togo?
Your response must be concise. -21.72. In the year 1979, what is the difference between the % of GDP of Portugal and % of GDP of Togo?
Your answer should be compact. -18.23. What is the ratio of the % of GDP in Heavily indebted poor countries in 1972 to that in 1973?
Your response must be concise. 0.95. What is the ratio of the % of GDP of Israel in 1972 to that in 1973?
Ensure brevity in your answer.  1.21. What is the ratio of the % of GDP of Portugal in 1972 to that in 1973?
Your answer should be compact. 0.92. What is the ratio of the % of GDP of Togo in 1972 to that in 1973?
Ensure brevity in your answer.  0.95. What is the ratio of the % of GDP in Heavily indebted poor countries in 1972 to that in 1974?
Your answer should be very brief. 0.87. What is the ratio of the % of GDP of Israel in 1972 to that in 1974?
Offer a terse response. 0.88. What is the ratio of the % of GDP in Portugal in 1972 to that in 1974?
Offer a terse response. 0.97. What is the ratio of the % of GDP in Togo in 1972 to that in 1974?
Offer a very short reply. 1.26. What is the ratio of the % of GDP in Heavily indebted poor countries in 1972 to that in 1975?
Keep it short and to the point. 0.85. What is the ratio of the % of GDP of Israel in 1972 to that in 1975?
Your response must be concise. 1. What is the ratio of the % of GDP of Portugal in 1972 to that in 1975?
Give a very brief answer. 1.48. What is the ratio of the % of GDP of Togo in 1972 to that in 1975?
Provide a short and direct response. 0.75. What is the ratio of the % of GDP of Heavily indebted poor countries in 1972 to that in 1976?
Make the answer very short. 0.92. What is the ratio of the % of GDP of Israel in 1972 to that in 1976?
Your response must be concise. 1.15. What is the ratio of the % of GDP in Portugal in 1972 to that in 1976?
Offer a terse response. 1.16. What is the ratio of the % of GDP in Togo in 1972 to that in 1976?
Provide a short and direct response. 0.83. What is the ratio of the % of GDP of Heavily indebted poor countries in 1972 to that in 1977?
Offer a very short reply. 0.85. What is the ratio of the % of GDP of Israel in 1972 to that in 1977?
Offer a terse response. 1.28. What is the ratio of the % of GDP in Portugal in 1972 to that in 1977?
Your answer should be very brief. 0.95. What is the ratio of the % of GDP in Togo in 1972 to that in 1977?
Offer a very short reply. 0.6. What is the ratio of the % of GDP in Heavily indebted poor countries in 1972 to that in 1978?
Ensure brevity in your answer.  0.84. What is the ratio of the % of GDP of Israel in 1972 to that in 1978?
Your answer should be compact. 1.16. What is the ratio of the % of GDP of Portugal in 1972 to that in 1978?
Keep it short and to the point. 0.91. What is the ratio of the % of GDP in Togo in 1972 to that in 1978?
Keep it short and to the point. 0.39. What is the ratio of the % of GDP in Heavily indebted poor countries in 1972 to that in 1979?
Keep it short and to the point. 0.91. What is the ratio of the % of GDP in Israel in 1972 to that in 1979?
Your answer should be compact. 1.15. What is the ratio of the % of GDP in Portugal in 1972 to that in 1979?
Offer a very short reply. 0.94. What is the ratio of the % of GDP of Togo in 1972 to that in 1979?
Your answer should be very brief. 0.42. What is the ratio of the % of GDP in Heavily indebted poor countries in 1973 to that in 1974?
Make the answer very short. 0.92. What is the ratio of the % of GDP in Israel in 1973 to that in 1974?
Offer a very short reply. 0.72. What is the ratio of the % of GDP of Portugal in 1973 to that in 1974?
Offer a very short reply. 1.05. What is the ratio of the % of GDP of Togo in 1973 to that in 1974?
Your answer should be very brief. 1.33. What is the ratio of the % of GDP of Heavily indebted poor countries in 1973 to that in 1975?
Provide a succinct answer. 0.9. What is the ratio of the % of GDP of Israel in 1973 to that in 1975?
Give a very brief answer. 0.82. What is the ratio of the % of GDP of Portugal in 1973 to that in 1975?
Offer a very short reply. 1.61. What is the ratio of the % of GDP of Togo in 1973 to that in 1975?
Provide a succinct answer. 0.79. What is the ratio of the % of GDP in Heavily indebted poor countries in 1973 to that in 1976?
Keep it short and to the point. 0.97. What is the ratio of the % of GDP of Israel in 1973 to that in 1976?
Offer a terse response. 0.95. What is the ratio of the % of GDP in Portugal in 1973 to that in 1976?
Offer a very short reply. 1.26. What is the ratio of the % of GDP of Togo in 1973 to that in 1976?
Keep it short and to the point. 0.87. What is the ratio of the % of GDP in Heavily indebted poor countries in 1973 to that in 1977?
Your answer should be compact. 0.9. What is the ratio of the % of GDP of Israel in 1973 to that in 1977?
Your response must be concise. 1.06. What is the ratio of the % of GDP in Portugal in 1973 to that in 1977?
Ensure brevity in your answer.  1.04. What is the ratio of the % of GDP in Togo in 1973 to that in 1977?
Provide a short and direct response. 0.63. What is the ratio of the % of GDP of Heavily indebted poor countries in 1973 to that in 1978?
Give a very brief answer. 0.89. What is the ratio of the % of GDP of Israel in 1973 to that in 1978?
Keep it short and to the point. 0.95. What is the ratio of the % of GDP in Togo in 1973 to that in 1978?
Keep it short and to the point. 0.41. What is the ratio of the % of GDP in Heavily indebted poor countries in 1973 to that in 1979?
Give a very brief answer. 0.96. What is the ratio of the % of GDP in Israel in 1973 to that in 1979?
Make the answer very short. 0.95. What is the ratio of the % of GDP of Portugal in 1973 to that in 1979?
Your answer should be very brief. 1.02. What is the ratio of the % of GDP in Togo in 1973 to that in 1979?
Offer a terse response. 0.45. What is the ratio of the % of GDP in Heavily indebted poor countries in 1974 to that in 1975?
Offer a very short reply. 0.98. What is the ratio of the % of GDP of Israel in 1974 to that in 1975?
Provide a short and direct response. 1.14. What is the ratio of the % of GDP of Portugal in 1974 to that in 1975?
Your answer should be very brief. 1.52. What is the ratio of the % of GDP in Togo in 1974 to that in 1975?
Your answer should be very brief. 0.59. What is the ratio of the % of GDP in Heavily indebted poor countries in 1974 to that in 1976?
Offer a very short reply. 1.06. What is the ratio of the % of GDP in Israel in 1974 to that in 1976?
Your answer should be compact. 1.31. What is the ratio of the % of GDP in Portugal in 1974 to that in 1976?
Your answer should be very brief. 1.2. What is the ratio of the % of GDP in Togo in 1974 to that in 1976?
Your answer should be compact. 0.66. What is the ratio of the % of GDP in Heavily indebted poor countries in 1974 to that in 1977?
Your answer should be compact. 0.98. What is the ratio of the % of GDP of Israel in 1974 to that in 1977?
Offer a terse response. 1.46. What is the ratio of the % of GDP of Portugal in 1974 to that in 1977?
Offer a terse response. 0.98. What is the ratio of the % of GDP of Togo in 1974 to that in 1977?
Give a very brief answer. 0.48. What is the ratio of the % of GDP in Heavily indebted poor countries in 1974 to that in 1978?
Give a very brief answer. 0.97. What is the ratio of the % of GDP in Israel in 1974 to that in 1978?
Your response must be concise. 1.32. What is the ratio of the % of GDP in Portugal in 1974 to that in 1978?
Keep it short and to the point. 0.94. What is the ratio of the % of GDP in Togo in 1974 to that in 1978?
Keep it short and to the point. 0.31. What is the ratio of the % of GDP of Heavily indebted poor countries in 1974 to that in 1979?
Your answer should be compact. 1.05. What is the ratio of the % of GDP in Israel in 1974 to that in 1979?
Offer a terse response. 1.32. What is the ratio of the % of GDP of Portugal in 1974 to that in 1979?
Your response must be concise. 0.97. What is the ratio of the % of GDP of Togo in 1974 to that in 1979?
Your answer should be compact. 0.34. What is the ratio of the % of GDP in Heavily indebted poor countries in 1975 to that in 1976?
Your answer should be very brief. 1.09. What is the ratio of the % of GDP of Israel in 1975 to that in 1976?
Provide a succinct answer. 1.15. What is the ratio of the % of GDP of Portugal in 1975 to that in 1976?
Your answer should be compact. 0.79. What is the ratio of the % of GDP of Togo in 1975 to that in 1976?
Give a very brief answer. 1.11. What is the ratio of the % of GDP in Heavily indebted poor countries in 1975 to that in 1977?
Provide a succinct answer. 1. What is the ratio of the % of GDP in Israel in 1975 to that in 1977?
Give a very brief answer. 1.28. What is the ratio of the % of GDP of Portugal in 1975 to that in 1977?
Keep it short and to the point. 0.65. What is the ratio of the % of GDP in Togo in 1975 to that in 1977?
Provide a short and direct response. 0.81. What is the ratio of the % of GDP in Heavily indebted poor countries in 1975 to that in 1978?
Your answer should be very brief. 0.99. What is the ratio of the % of GDP in Israel in 1975 to that in 1978?
Give a very brief answer. 1.16. What is the ratio of the % of GDP of Portugal in 1975 to that in 1978?
Keep it short and to the point. 0.62. What is the ratio of the % of GDP in Togo in 1975 to that in 1978?
Provide a succinct answer. 0.53. What is the ratio of the % of GDP of Heavily indebted poor countries in 1975 to that in 1979?
Make the answer very short. 1.07. What is the ratio of the % of GDP in Israel in 1975 to that in 1979?
Your answer should be compact. 1.15. What is the ratio of the % of GDP of Portugal in 1975 to that in 1979?
Make the answer very short. 0.64. What is the ratio of the % of GDP of Togo in 1975 to that in 1979?
Your answer should be compact. 0.57. What is the ratio of the % of GDP in Heavily indebted poor countries in 1976 to that in 1977?
Offer a terse response. 0.92. What is the ratio of the % of GDP in Israel in 1976 to that in 1977?
Your response must be concise. 1.12. What is the ratio of the % of GDP in Portugal in 1976 to that in 1977?
Your response must be concise. 0.82. What is the ratio of the % of GDP in Togo in 1976 to that in 1977?
Ensure brevity in your answer.  0.72. What is the ratio of the % of GDP of Heavily indebted poor countries in 1976 to that in 1978?
Give a very brief answer. 0.91. What is the ratio of the % of GDP of Israel in 1976 to that in 1978?
Your answer should be compact. 1.01. What is the ratio of the % of GDP in Portugal in 1976 to that in 1978?
Offer a very short reply. 0.78. What is the ratio of the % of GDP of Togo in 1976 to that in 1978?
Offer a very short reply. 0.47. What is the ratio of the % of GDP in Heavily indebted poor countries in 1976 to that in 1979?
Your answer should be very brief. 0.99. What is the ratio of the % of GDP of Portugal in 1976 to that in 1979?
Give a very brief answer. 0.81. What is the ratio of the % of GDP in Togo in 1976 to that in 1979?
Your response must be concise. 0.51. What is the ratio of the % of GDP in Israel in 1977 to that in 1978?
Keep it short and to the point. 0.9. What is the ratio of the % of GDP of Portugal in 1977 to that in 1978?
Keep it short and to the point. 0.95. What is the ratio of the % of GDP of Togo in 1977 to that in 1978?
Provide a succinct answer. 0.65. What is the ratio of the % of GDP in Heavily indebted poor countries in 1977 to that in 1979?
Provide a short and direct response. 1.07. What is the ratio of the % of GDP of Israel in 1977 to that in 1979?
Provide a succinct answer. 0.9. What is the ratio of the % of GDP in Portugal in 1977 to that in 1979?
Keep it short and to the point. 0.98. What is the ratio of the % of GDP in Togo in 1977 to that in 1979?
Offer a very short reply. 0.7. What is the ratio of the % of GDP in Heavily indebted poor countries in 1978 to that in 1979?
Make the answer very short. 1.08. What is the ratio of the % of GDP of Israel in 1978 to that in 1979?
Provide a succinct answer. 1. What is the ratio of the % of GDP of Portugal in 1978 to that in 1979?
Offer a terse response. 1.03. What is the ratio of the % of GDP of Togo in 1978 to that in 1979?
Offer a very short reply. 1.08. What is the difference between the highest and the second highest % of GDP in Heavily indebted poor countries?
Give a very brief answer. 0.15. What is the difference between the highest and the second highest % of GDP of Israel?
Your answer should be very brief. 4.46. What is the difference between the highest and the second highest % of GDP of Portugal?
Ensure brevity in your answer.  0.35. What is the difference between the highest and the second highest % of GDP of Togo?
Make the answer very short. 3.87. What is the difference between the highest and the lowest % of GDP in Heavily indebted poor countries?
Your answer should be compact. 3.09. What is the difference between the highest and the lowest % of GDP in Israel?
Provide a short and direct response. 11.34. What is the difference between the highest and the lowest % of GDP in Portugal?
Make the answer very short. 12.16. What is the difference between the highest and the lowest % of GDP in Togo?
Make the answer very short. 36.31. 